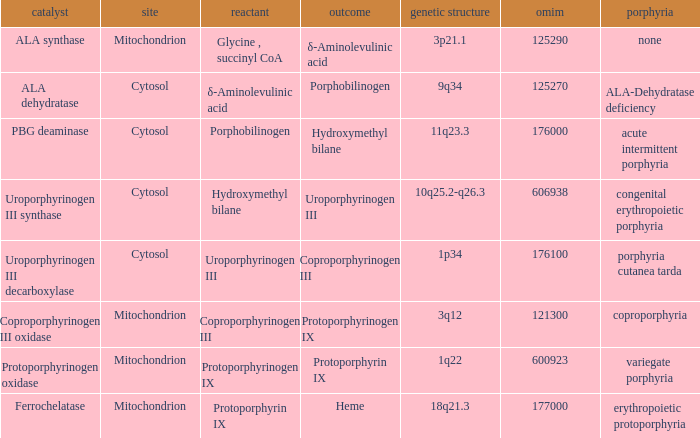What is protoporphyrin ix's substrate? Protoporphyrinogen IX. 